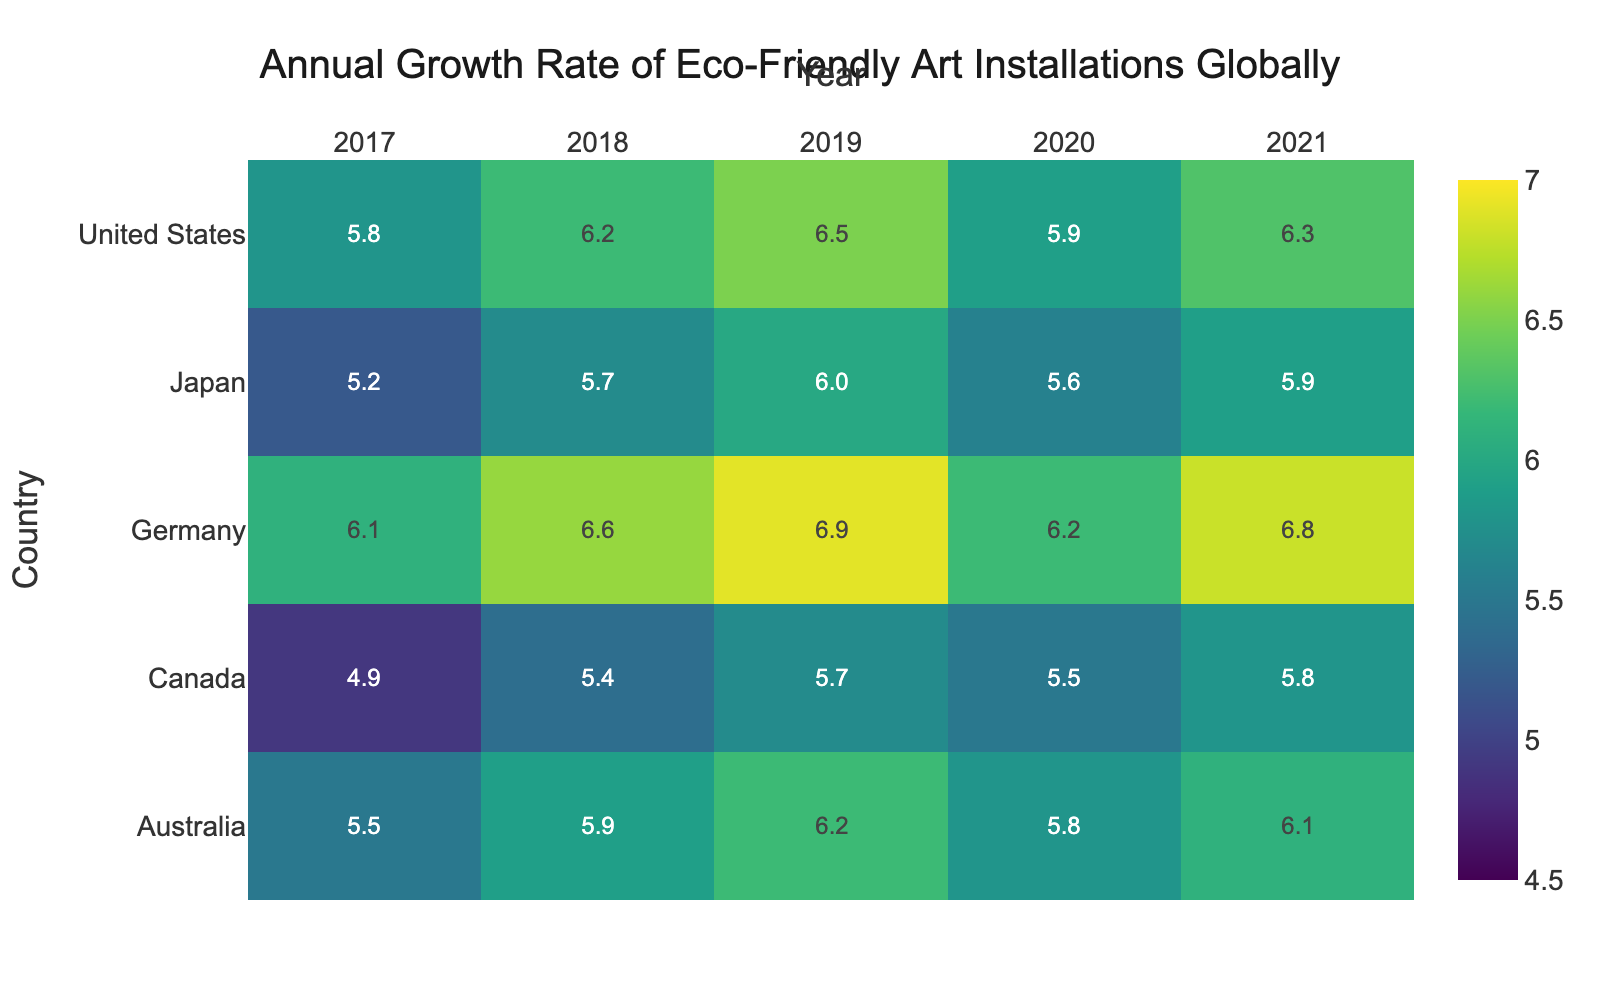What is the title of the heatmap? The title is typically mentioned prominently at the top of the figure. The title of the heatmap is given as part of the layout settings.
Answer: Annual Growth Rate of Eco-Friendly Art Installations Globally Which country had the highest growth rate in 2019? To find this, look at the column for the year 2019 and identify the highest value. According to the heatmap, Germany had the highest growth rate in 2019.
Answer: Germany What is the range of values (minimum and maximum) represented on the heatmap? The color scale settings for the heatmap indicate the range of values. The minimum value is 4.5 and the maximum value is 7.
Answer: 4.5 to 7 How does Japan's growth rate in 2019 compare to Japan's growth rate in 2020? Locate Japan's growth rates for the years 2019 and 2020 from the heatmap. Compare the values: Japan had a growth rate of 6.0 in 2019 and 5.6 in 2020.
Answer: It decreased from 6.0 to 5.6 What is the average growth rate for the United States over the years 2017 to 2021? Sum the annual growth rates for the United States from 2017 to 2021, then divide by the number of years. The values are: 5.8 + 6.2 + 6.5 + 5.9 + 6.3, so the average is (30.7 / 5).
Answer: 6.14 Which country had the smallest growth rate in 2018? Look at the column for 2018 and find the smallest value. The growth rates for 2018 are: United States (6.2), Canada (5.4), Germany (6.6), Japan (5.7), Australia (5.9). The smallest is Canada's 5.4.
Answer: Canada Did any country's growth rate decrease from 2019 to 2020? Compare the growth rates for 2019 and 2020 for each country. If a country's 2020 rate is less than its 2019 rate, it decreased. The countries with decreasing rates are the United States, Canada, Germany, and Japan.
Answer: Yes Compare the growth rate trends of Germany and Australia between 2017 and 2021. Examine the values for each year for both countries. Germany's rates are: 6.1, 6.6, 6.9, 6.2, 6.8. Australia's rates are: 5.5, 5.9, 6.2, 5.8, 6.1. Germany generally had higher rates and more fluctuation.
Answer: Germany had higher and more fluctuating rates Which year had the highest average growth rate across all countries? Find the average growth rate for each year by summing the values for all countries in that year and dividing by five (the number of countries). The averages are: 2017 (5.5), 2018 (6.0), 2019 (6.26), 2020 (5.8), 2021 (6.18).
Answer: 2019 